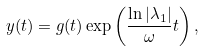Convert formula to latex. <formula><loc_0><loc_0><loc_500><loc_500>y ( t ) = g ( t ) \exp \left ( \frac { \ln | \lambda _ { 1 } | } { \omega } t \right ) ,</formula> 